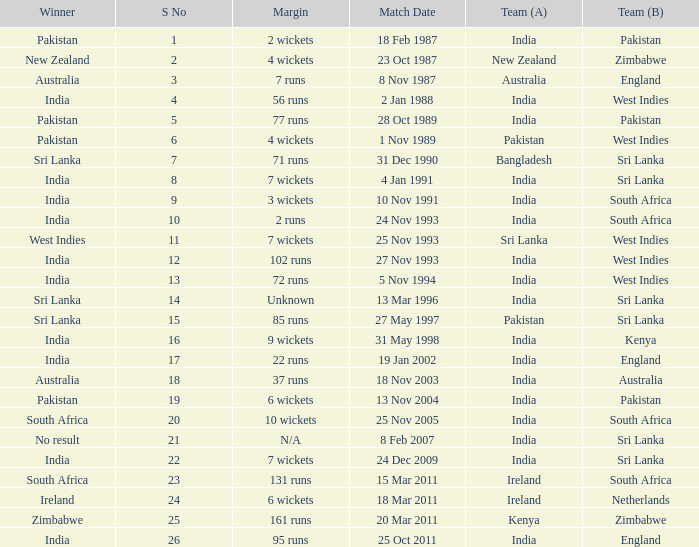Can you parse all the data within this table? {'header': ['Winner', 'S No', 'Margin', 'Match Date', 'Team (A)', 'Team (B)'], 'rows': [['Pakistan', '1', '2 wickets', '18 Feb 1987', 'India', 'Pakistan'], ['New Zealand', '2', '4 wickets', '23 Oct 1987', 'New Zealand', 'Zimbabwe'], ['Australia', '3', '7 runs', '8 Nov 1987', 'Australia', 'England'], ['India', '4', '56 runs', '2 Jan 1988', 'India', 'West Indies'], ['Pakistan', '5', '77 runs', '28 Oct 1989', 'India', 'Pakistan'], ['Pakistan', '6', '4 wickets', '1 Nov 1989', 'Pakistan', 'West Indies'], ['Sri Lanka', '7', '71 runs', '31 Dec 1990', 'Bangladesh', 'Sri Lanka'], ['India', '8', '7 wickets', '4 Jan 1991', 'India', 'Sri Lanka'], ['India', '9', '3 wickets', '10 Nov 1991', 'India', 'South Africa'], ['India', '10', '2 runs', '24 Nov 1993', 'India', 'South Africa'], ['West Indies', '11', '7 wickets', '25 Nov 1993', 'Sri Lanka', 'West Indies'], ['India', '12', '102 runs', '27 Nov 1993', 'India', 'West Indies'], ['India', '13', '72 runs', '5 Nov 1994', 'India', 'West Indies'], ['Sri Lanka', '14', 'Unknown', '13 Mar 1996', 'India', 'Sri Lanka'], ['Sri Lanka', '15', '85 runs', '27 May 1997', 'Pakistan', 'Sri Lanka'], ['India', '16', '9 wickets', '31 May 1998', 'India', 'Kenya'], ['India', '17', '22 runs', '19 Jan 2002', 'India', 'England'], ['Australia', '18', '37 runs', '18 Nov 2003', 'India', 'Australia'], ['Pakistan', '19', '6 wickets', '13 Nov 2004', 'India', 'Pakistan'], ['South Africa', '20', '10 wickets', '25 Nov 2005', 'India', 'South Africa'], ['No result', '21', 'N/A', '8 Feb 2007', 'India', 'Sri Lanka'], ['India', '22', '7 wickets', '24 Dec 2009', 'India', 'Sri Lanka'], ['South Africa', '23', '131 runs', '15 Mar 2011', 'Ireland', 'South Africa'], ['Ireland', '24', '6 wickets', '18 Mar 2011', 'Ireland', 'Netherlands'], ['Zimbabwe', '25', '161 runs', '20 Mar 2011', 'Kenya', 'Zimbabwe'], ['India', '26', '95 runs', '25 Oct 2011', 'India', 'England']]} How many games were won by a margin of 131 runs? 1.0. 